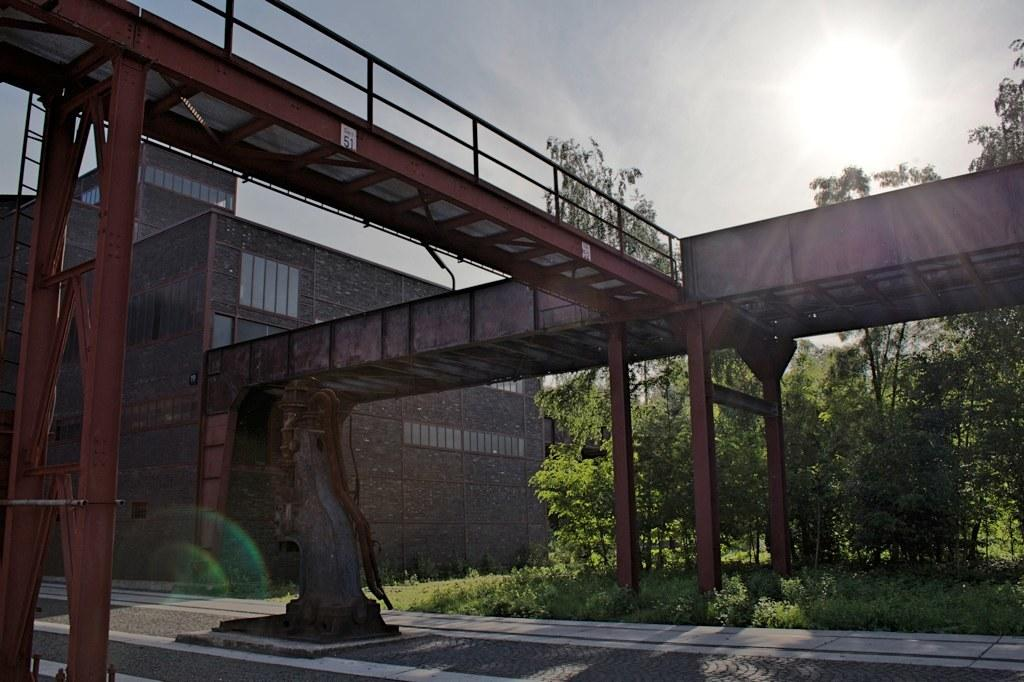What type of structure is present in the image? There is a bridge in the image. What other structures can be seen in the image? There is a building in the image. What type of natural elements are present in the image? There are trees in the image. What is at the bottom of the image? There is a road and ground at the bottom of the image. What is visible at the top of the image? The sun is visible at the top of the image. Where is the advertisement for the camera located in the image? There is no advertisement for a camera present in the image. Is there any blood visible in the image? There is no blood visible in the image. 